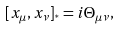Convert formula to latex. <formula><loc_0><loc_0><loc_500><loc_500>[ x _ { \mu } , x _ { \nu } ] _ { ^ { * } } = i \Theta _ { \mu \nu } ,</formula> 